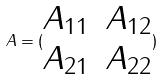Convert formula to latex. <formula><loc_0><loc_0><loc_500><loc_500>A = ( \begin{matrix} A _ { 1 1 } & A _ { 1 2 } \\ A _ { 2 1 } & A _ { 2 2 } \end{matrix} )</formula> 